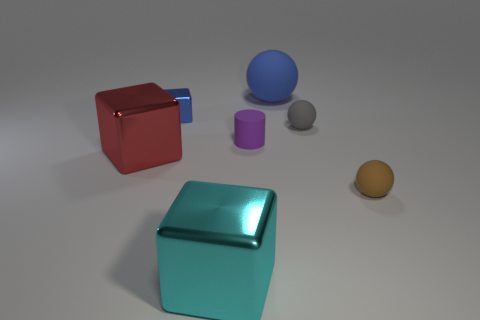Is the number of small brown objects that are behind the gray thing greater than the number of big blue matte spheres to the left of the big red block?
Keep it short and to the point. No. There is a tiny thing that is right of the tiny purple thing and in front of the gray rubber object; what is its material?
Keep it short and to the point. Rubber. The small metal object that is the same shape as the large red metallic object is what color?
Give a very brief answer. Blue. What is the size of the blue ball?
Ensure brevity in your answer.  Large. There is a small object right of the tiny matte object behind the purple rubber object; what is its color?
Your answer should be very brief. Brown. How many rubber objects are both behind the big red metal object and on the right side of the purple matte thing?
Give a very brief answer. 2. Are there more red objects than small rubber objects?
Your answer should be very brief. No. What is the brown thing made of?
Give a very brief answer. Rubber. There is a metal block behind the tiny purple cylinder; what number of rubber cylinders are to the right of it?
Keep it short and to the point. 1. There is a tiny cylinder; is its color the same as the small object behind the gray matte thing?
Make the answer very short. No. 